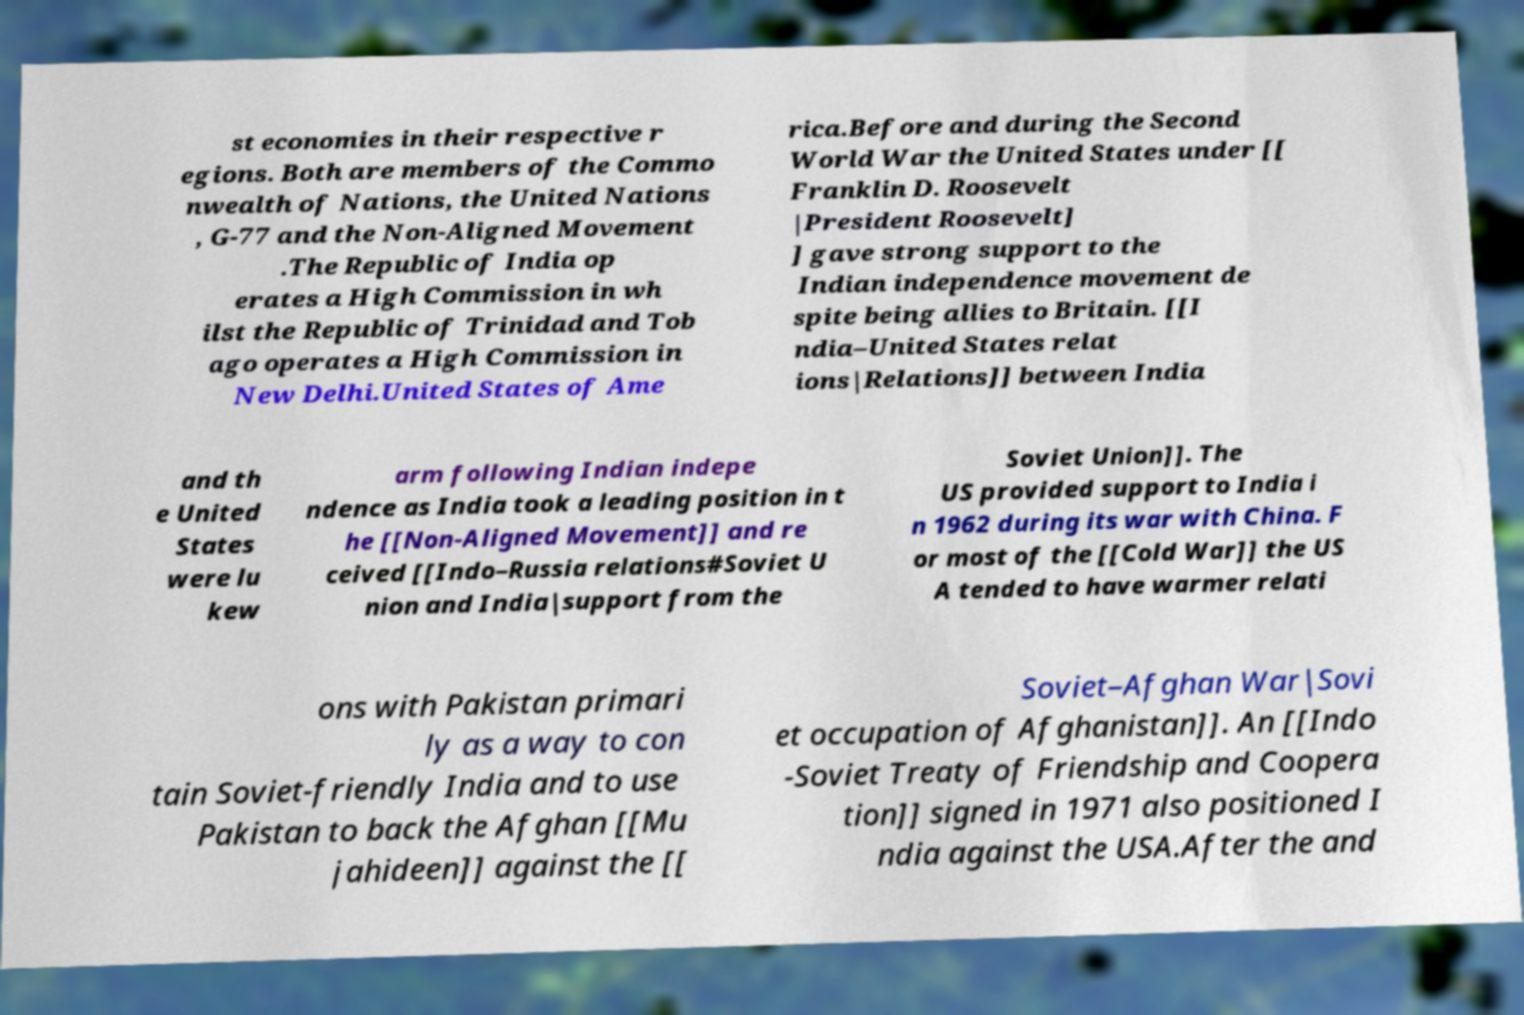What messages or text are displayed in this image? I need them in a readable, typed format. st economies in their respective r egions. Both are members of the Commo nwealth of Nations, the United Nations , G-77 and the Non-Aligned Movement .The Republic of India op erates a High Commission in wh ilst the Republic of Trinidad and Tob ago operates a High Commission in New Delhi.United States of Ame rica.Before and during the Second World War the United States under [[ Franklin D. Roosevelt |President Roosevelt] ] gave strong support to the Indian independence movement de spite being allies to Britain. [[I ndia–United States relat ions|Relations]] between India and th e United States were lu kew arm following Indian indepe ndence as India took a leading position in t he [[Non-Aligned Movement]] and re ceived [[Indo–Russia relations#Soviet U nion and India|support from the Soviet Union]]. The US provided support to India i n 1962 during its war with China. F or most of the [[Cold War]] the US A tended to have warmer relati ons with Pakistan primari ly as a way to con tain Soviet-friendly India and to use Pakistan to back the Afghan [[Mu jahideen]] against the [[ Soviet–Afghan War|Sovi et occupation of Afghanistan]]. An [[Indo -Soviet Treaty of Friendship and Coopera tion]] signed in 1971 also positioned I ndia against the USA.After the and 